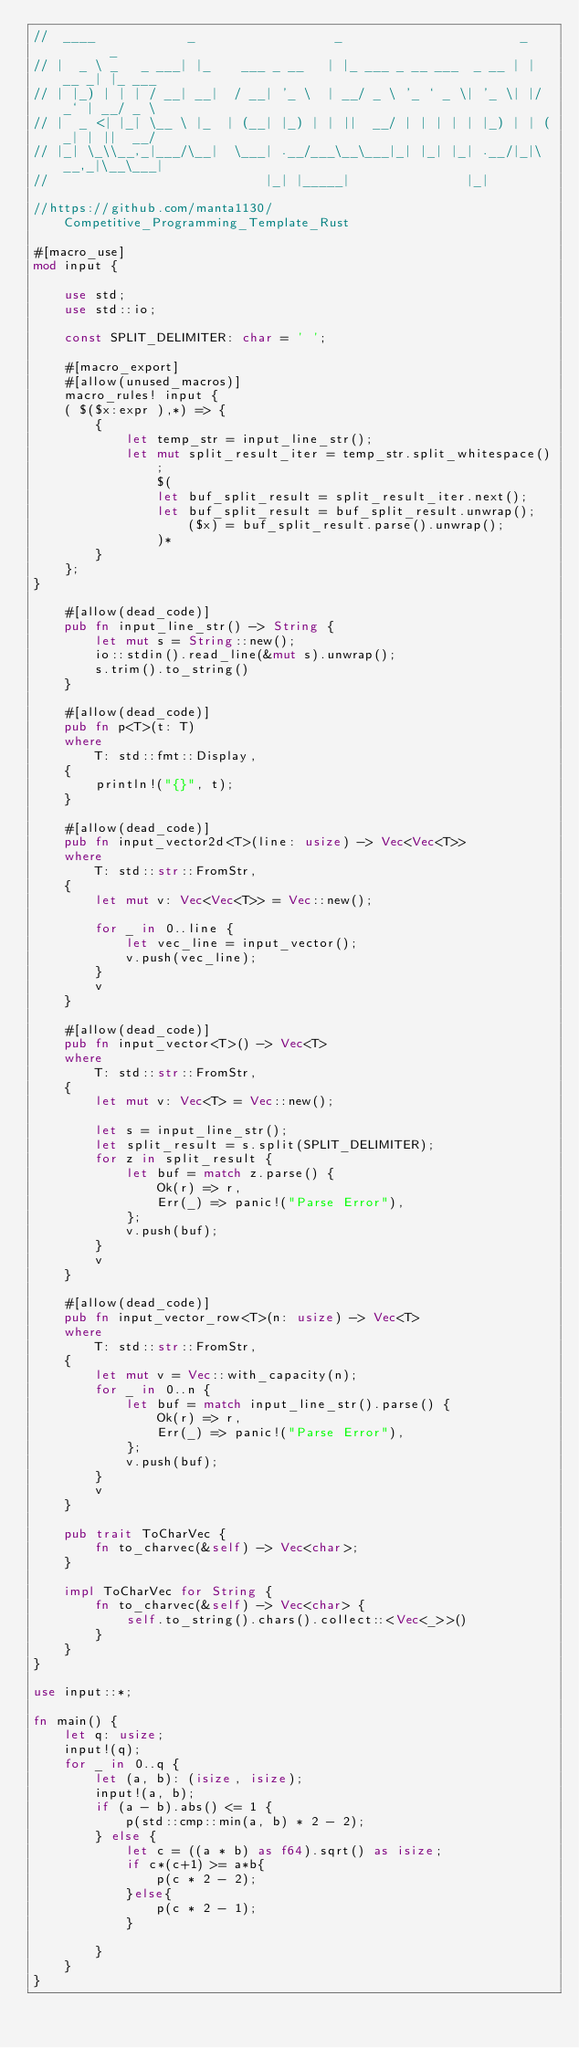Convert code to text. <code><loc_0><loc_0><loc_500><loc_500><_Rust_>//  ____            _                  _                       _       _
// |  _ \ _   _ ___| |_    ___ _ __   | |_ ___ _ __ ___  _ __ | | __ _| |_ ___
// | |_) | | | / __| __|  / __| '_ \  | __/ _ \ '_ ` _ \| '_ \| |/ _` | __/ _ \
// |  _ <| |_| \__ \ |_  | (__| |_) | | ||  __/ | | | | | |_) | | (_| | ||  __/
// |_| \_\\__,_|___/\__|  \___| .__/___\__\___|_| |_| |_| .__/|_|\__,_|\__\___|
//                            |_| |_____|               |_|

//https://github.com/manta1130/Competitive_Programming_Template_Rust

#[macro_use]
mod input {

    use std;
    use std::io;

    const SPLIT_DELIMITER: char = ' ';

    #[macro_export]
    #[allow(unused_macros)]
    macro_rules! input {
    ( $($x:expr ),*) => {
        {
            let temp_str = input_line_str();
            let mut split_result_iter = temp_str.split_whitespace();
                $(
                let buf_split_result = split_result_iter.next();
                let buf_split_result = buf_split_result.unwrap();
                    ($x) = buf_split_result.parse().unwrap();
                )*
        }
    };
}

    #[allow(dead_code)]
    pub fn input_line_str() -> String {
        let mut s = String::new();
        io::stdin().read_line(&mut s).unwrap();
        s.trim().to_string()
    }

    #[allow(dead_code)]
    pub fn p<T>(t: T)
    where
        T: std::fmt::Display,
    {
        println!("{}", t);
    }

    #[allow(dead_code)]
    pub fn input_vector2d<T>(line: usize) -> Vec<Vec<T>>
    where
        T: std::str::FromStr,
    {
        let mut v: Vec<Vec<T>> = Vec::new();

        for _ in 0..line {
            let vec_line = input_vector();
            v.push(vec_line);
        }
        v
    }

    #[allow(dead_code)]
    pub fn input_vector<T>() -> Vec<T>
    where
        T: std::str::FromStr,
    {
        let mut v: Vec<T> = Vec::new();

        let s = input_line_str();
        let split_result = s.split(SPLIT_DELIMITER);
        for z in split_result {
            let buf = match z.parse() {
                Ok(r) => r,
                Err(_) => panic!("Parse Error"),
            };
            v.push(buf);
        }
        v
    }

    #[allow(dead_code)]
    pub fn input_vector_row<T>(n: usize) -> Vec<T>
    where
        T: std::str::FromStr,
    {
        let mut v = Vec::with_capacity(n);
        for _ in 0..n {
            let buf = match input_line_str().parse() {
                Ok(r) => r,
                Err(_) => panic!("Parse Error"),
            };
            v.push(buf);
        }
        v
    }

    pub trait ToCharVec {
        fn to_charvec(&self) -> Vec<char>;
    }

    impl ToCharVec for String {
        fn to_charvec(&self) -> Vec<char> {
            self.to_string().chars().collect::<Vec<_>>()
        }
    }
}

use input::*;

fn main() {
    let q: usize;
    input!(q);
    for _ in 0..q {
        let (a, b): (isize, isize);
        input!(a, b);
        if (a - b).abs() <= 1 {
            p(std::cmp::min(a, b) * 2 - 2);
        } else {
            let c = ((a * b) as f64).sqrt() as isize;
            if c*(c+1) >= a*b{
                p(c * 2 - 2);
            }else{
                p(c * 2 - 1);
            }
            
        }
    }
}
</code> 